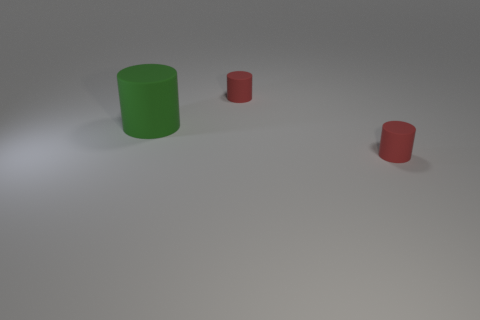How many other objects have the same color as the big thing?
Give a very brief answer. 0. What number of rubber objects are either tiny red things or large objects?
Offer a very short reply. 3. Does the red object in front of the big green rubber cylinder have the same shape as the red object that is behind the big thing?
Offer a terse response. Yes. There is a big green cylinder; what number of red things are in front of it?
Your answer should be very brief. 1. Are there any big green things made of the same material as the big cylinder?
Offer a terse response. No. How many things are either green cylinders or large brown cylinders?
Offer a terse response. 1. What is the shape of the red object that is behind the large object?
Offer a terse response. Cylinder. The large matte thing is what shape?
Ensure brevity in your answer.  Cylinder. What size is the cylinder that is to the left of the cylinder behind the big matte cylinder?
Provide a succinct answer. Large. What number of other things are there of the same color as the big rubber cylinder?
Ensure brevity in your answer.  0. 